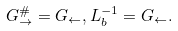<formula> <loc_0><loc_0><loc_500><loc_500>G _ { \rightarrow } ^ { \# } = G _ { \leftarrow } , L _ { b } ^ { - 1 } = G _ { \leftarrow } .</formula> 